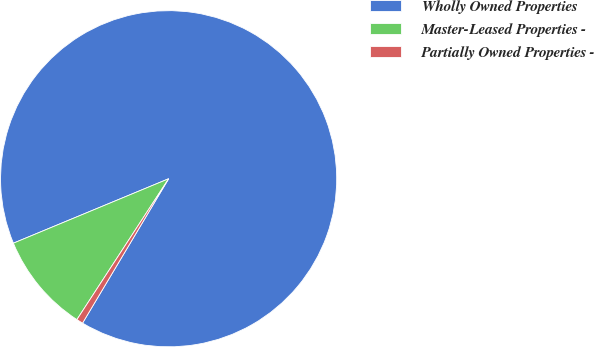Convert chart. <chart><loc_0><loc_0><loc_500><loc_500><pie_chart><fcel>Wholly Owned Properties<fcel>Master-Leased Properties -<fcel>Partially Owned Properties -<nl><fcel>89.81%<fcel>9.55%<fcel>0.63%<nl></chart> 